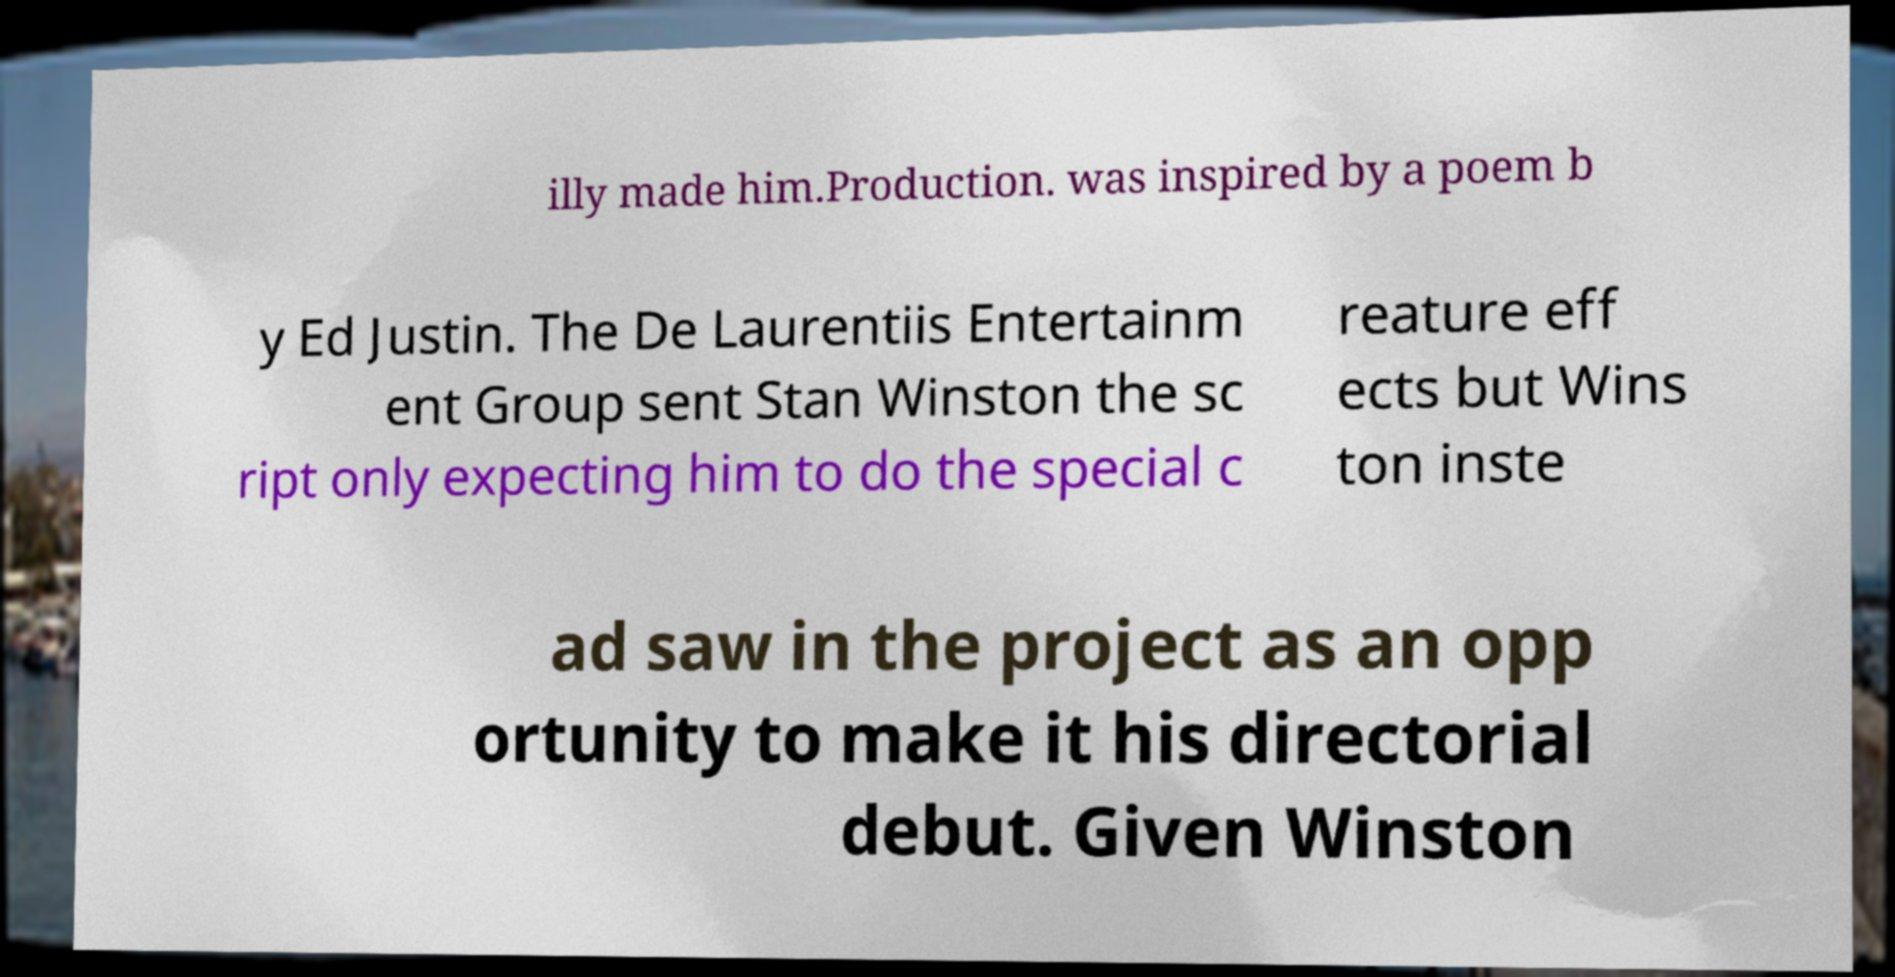For documentation purposes, I need the text within this image transcribed. Could you provide that? illy made him.Production. was inspired by a poem b y Ed Justin. The De Laurentiis Entertainm ent Group sent Stan Winston the sc ript only expecting him to do the special c reature eff ects but Wins ton inste ad saw in the project as an opp ortunity to make it his directorial debut. Given Winston 